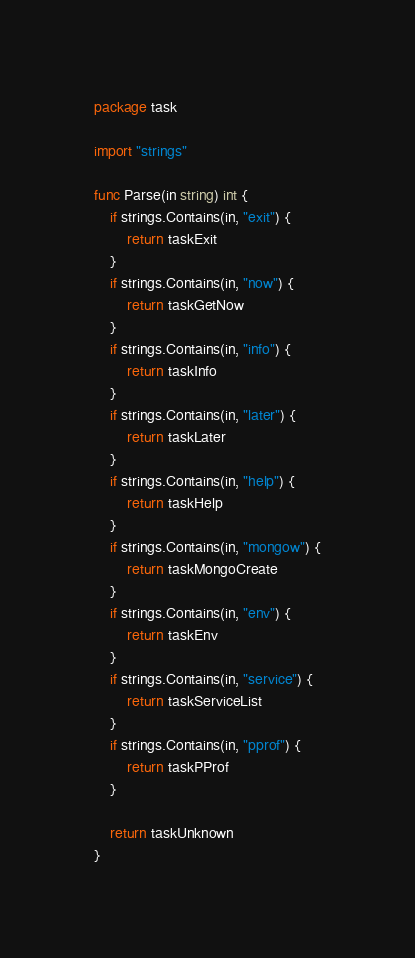Convert code to text. <code><loc_0><loc_0><loc_500><loc_500><_Go_>package task

import "strings"

func Parse(in string) int {
	if strings.Contains(in, "exit") {
		return taskExit
	}
	if strings.Contains(in, "now") {
		return taskGetNow
	}
	if strings.Contains(in, "info") {
		return taskInfo
	}
	if strings.Contains(in, "later") {
		return taskLater
	}
	if strings.Contains(in, "help") {
		return taskHelp
	}
	if strings.Contains(in, "mongow") {
		return taskMongoCreate
	}
	if strings.Contains(in, "env") {
		return taskEnv
	}
	if strings.Contains(in, "service") {
		return taskServiceList
	}
	if strings.Contains(in, "pprof") {
		return taskPProf
	}

	return taskUnknown
}
</code> 